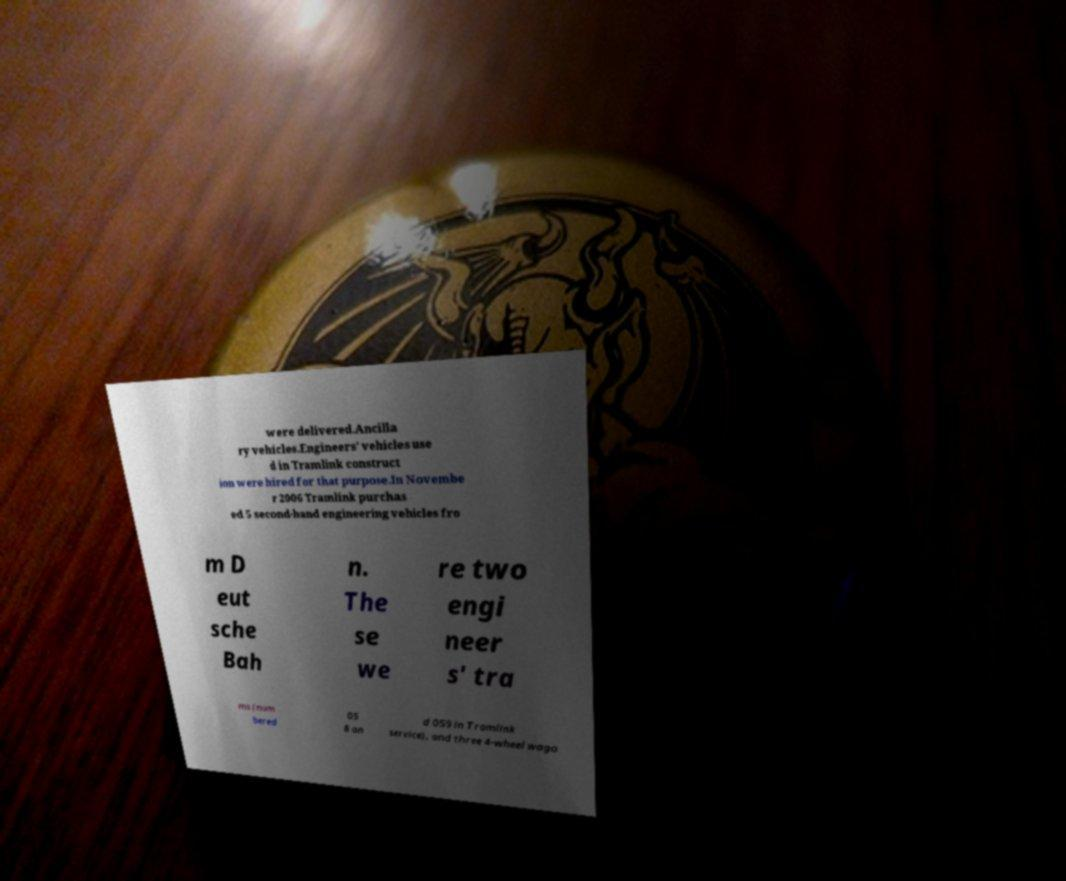Could you assist in decoding the text presented in this image and type it out clearly? were delivered.Ancilla ry vehicles.Engineers' vehicles use d in Tramlink construct ion were hired for that purpose.In Novembe r 2006 Tramlink purchas ed 5 second-hand engineering vehicles fro m D eut sche Bah n. The se we re two engi neer s' tra ms (num bered 05 8 an d 059 in Tramlink service), and three 4-wheel wago 